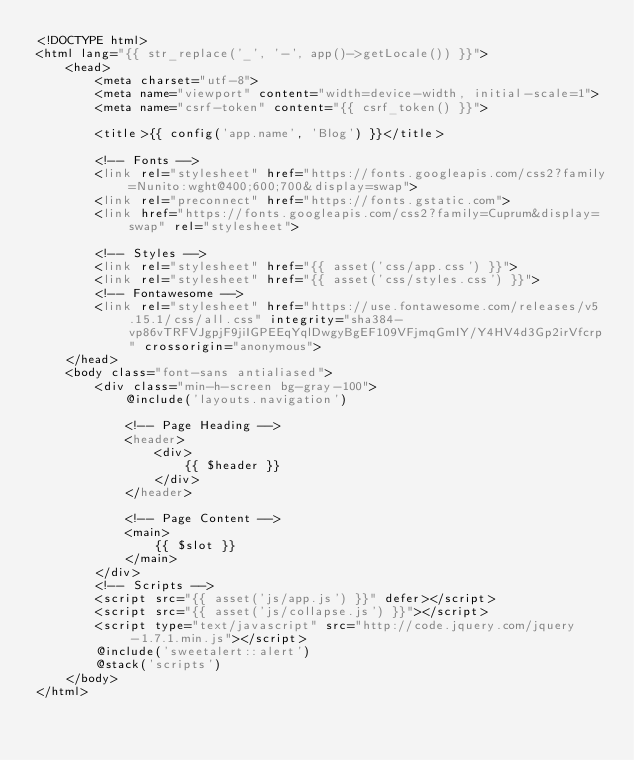<code> <loc_0><loc_0><loc_500><loc_500><_PHP_><!DOCTYPE html>
<html lang="{{ str_replace('_', '-', app()->getLocale()) }}">
    <head>
        <meta charset="utf-8">
        <meta name="viewport" content="width=device-width, initial-scale=1">
        <meta name="csrf-token" content="{{ csrf_token() }}">

        <title>{{ config('app.name', 'Blog') }}</title>

        <!-- Fonts -->
        <link rel="stylesheet" href="https://fonts.googleapis.com/css2?family=Nunito:wght@400;600;700&display=swap">
        <link rel="preconnect" href="https://fonts.gstatic.com">
        <link href="https://fonts.googleapis.com/css2?family=Cuprum&display=swap" rel="stylesheet">

        <!-- Styles -->
        <link rel="stylesheet" href="{{ asset('css/app.css') }}">
        <link rel="stylesheet" href="{{ asset('css/styles.css') }}">
        <!-- Fontawesome -->
        <link rel="stylesheet" href="https://use.fontawesome.com/releases/v5.15.1/css/all.css" integrity="sha384-vp86vTRFVJgpjF9jiIGPEEqYqlDwgyBgEF109VFjmqGmIY/Y4HV4d3Gp2irVfcrp" crossorigin="anonymous">
    </head>
    <body class="font-sans antialiased">
        <div class="min-h-screen bg-gray-100">
            @include('layouts.navigation')

            <!-- Page Heading -->
            <header>
                <div>
                    {{ $header }}
                </div>
            </header>

            <!-- Page Content -->
            <main>
                {{ $slot }}
            </main>
        </div>
        <!-- Scripts -->
        <script src="{{ asset('js/app.js') }}" defer></script>
        <script src="{{ asset('js/collapse.js') }}"></script>
        <script type="text/javascript" src="http://code.jquery.com/jquery-1.7.1.min.js"></script>
        @include('sweetalert::alert')
        @stack('scripts')
    </body>
</html>
</code> 